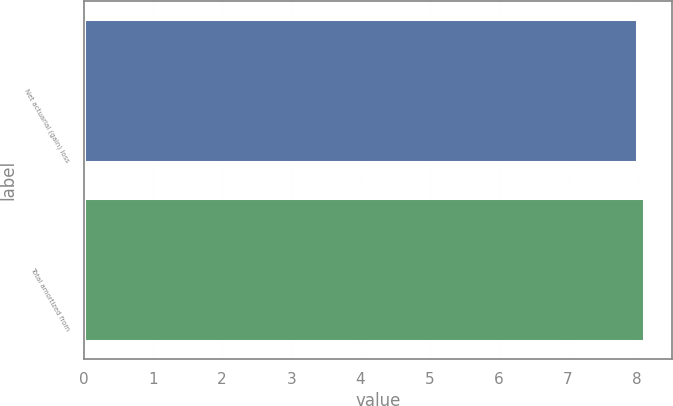<chart> <loc_0><loc_0><loc_500><loc_500><bar_chart><fcel>Net actuarial (gain) loss<fcel>Total amortized from<nl><fcel>8<fcel>8.1<nl></chart> 